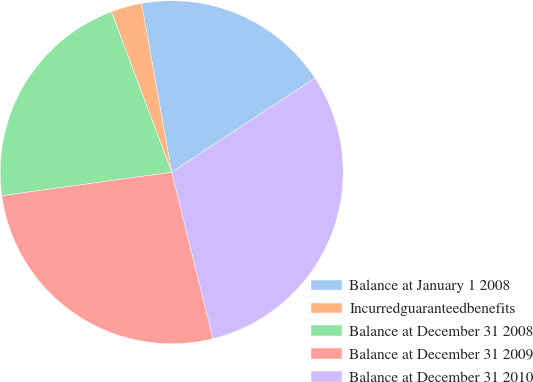<chart> <loc_0><loc_0><loc_500><loc_500><pie_chart><fcel>Balance at January 1 2008<fcel>Incurredguaranteedbenefits<fcel>Balance at December 31 2008<fcel>Balance at December 31 2009<fcel>Balance at December 31 2010<nl><fcel>18.56%<fcel>2.91%<fcel>21.47%<fcel>26.69%<fcel>30.37%<nl></chart> 